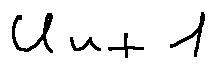<formula> <loc_0><loc_0><loc_500><loc_500>u _ { n + 1 }</formula> 